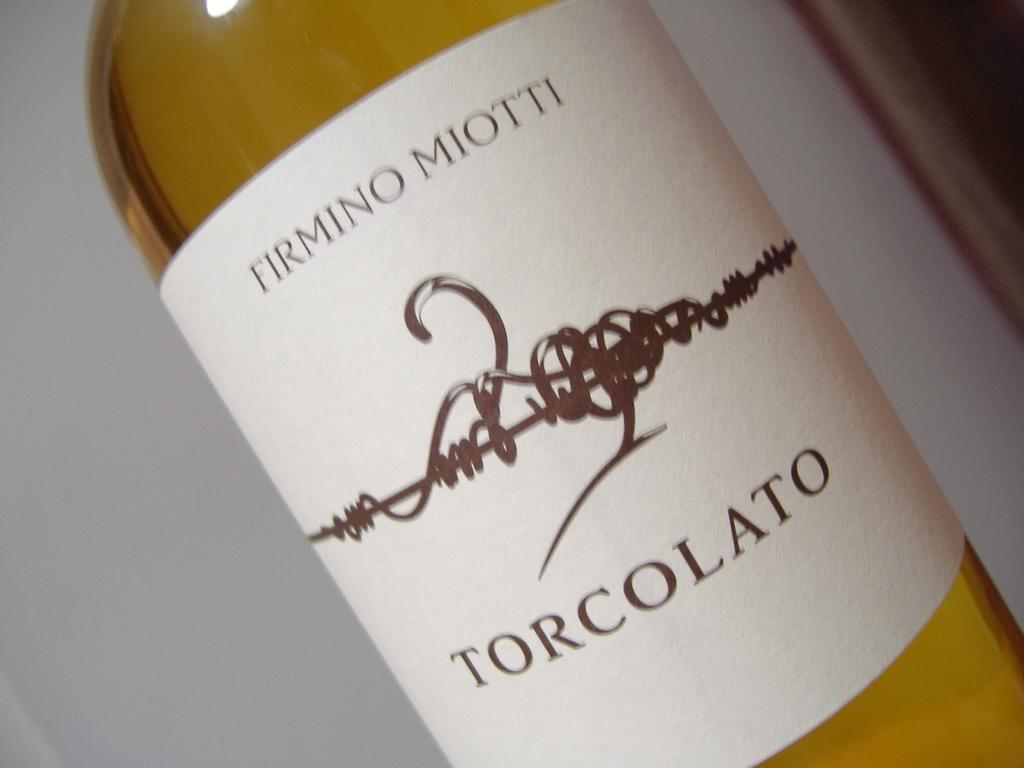<image>
Relay a brief, clear account of the picture shown. the word torcolato that is on a bottle 